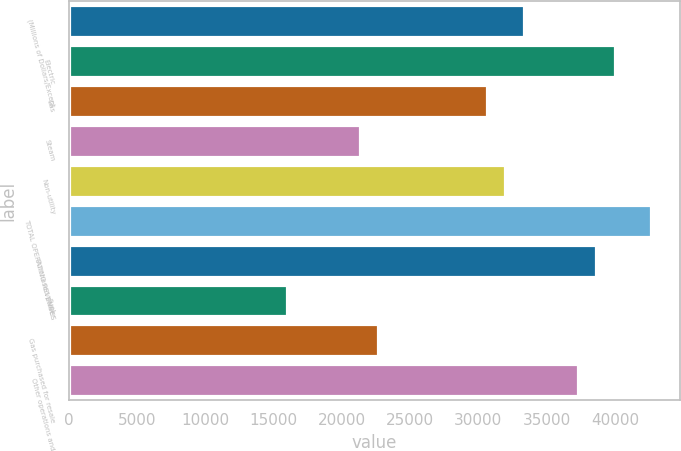Convert chart to OTSL. <chart><loc_0><loc_0><loc_500><loc_500><bar_chart><fcel>(Millions of Dollars/Except<fcel>Electric<fcel>Gas<fcel>Steam<fcel>Non-utility<fcel>TOTAL OPERATING REVENUES<fcel>Purchased power<fcel>Fuel<fcel>Gas purchased for resale<fcel>Other operations and<nl><fcel>33308.9<fcel>39970.2<fcel>30644.4<fcel>21318.5<fcel>31976.6<fcel>42634.7<fcel>38637.9<fcel>15989.5<fcel>22650.8<fcel>37305.7<nl></chart> 